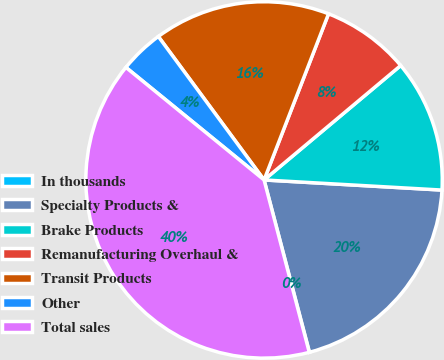<chart> <loc_0><loc_0><loc_500><loc_500><pie_chart><fcel>In thousands<fcel>Specialty Products &<fcel>Brake Products<fcel>Remanufacturing Overhaul &<fcel>Transit Products<fcel>Other<fcel>Total sales<nl><fcel>0.02%<fcel>19.99%<fcel>12.0%<fcel>8.01%<fcel>16.0%<fcel>4.01%<fcel>39.96%<nl></chart> 